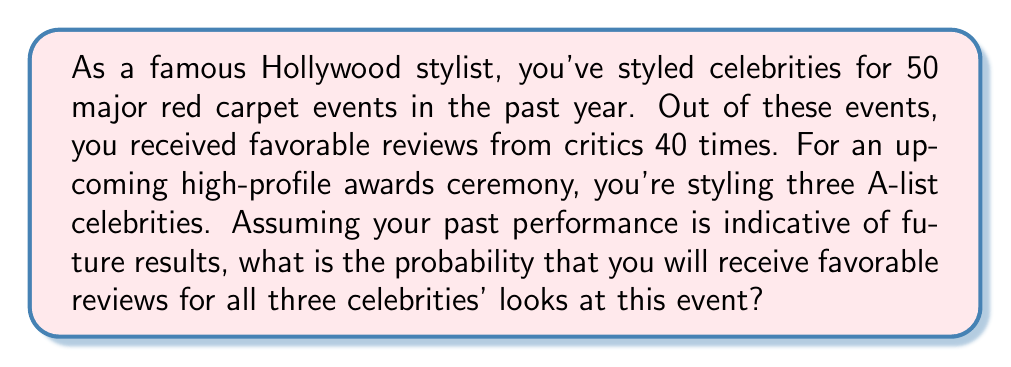Provide a solution to this math problem. Let's approach this step-by-step:

1) First, we need to calculate the probability of receiving a favorable review for a single styling:

   $P(\text{favorable review}) = \frac{\text{number of favorable reviews}}{\text{total number of events}}$

   $P(\text{favorable review}) = \frac{40}{50} = 0.8$ or 80%

2) Now, we need to find the probability of receiving favorable reviews for all three celebrities. Since these are independent events (the review for one celebrity doesn't affect the others), we can use the multiplication rule of probability.

3) The probability of all three events occurring is the product of their individual probabilities:

   $P(\text{all favorable}) = P(\text{favorable})^3$

4) Substituting our value:

   $P(\text{all favorable}) = 0.8^3$

5) Calculate:

   $P(\text{all favorable}) = 0.8 \times 0.8 \times 0.8 = 0.512$

Therefore, the probability of receiving favorable reviews for all three celebrities is 0.512 or 51.2%.
Answer: 0.512 or 51.2% 